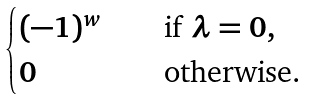Convert formula to latex. <formula><loc_0><loc_0><loc_500><loc_500>\begin{cases} ( - 1 ) ^ { w } \quad & \text {if $\lambda=0$} , \\ 0 \quad & \text {otherwise.} \end{cases}</formula> 